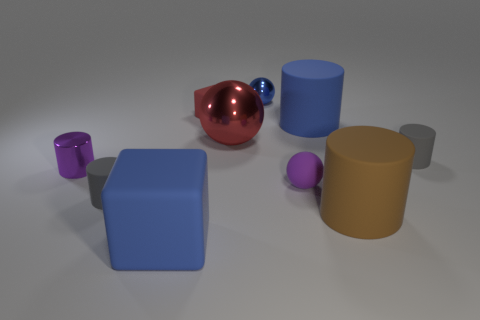Subtract all blue shiny spheres. How many spheres are left? 2 Subtract all gray blocks. How many gray cylinders are left? 2 Subtract all blue blocks. How many blocks are left? 1 Subtract 1 blocks. How many blocks are left? 1 Subtract all cubes. How many objects are left? 8 Subtract all large rubber things. Subtract all tiny red rubber cubes. How many objects are left? 6 Add 1 big cylinders. How many big cylinders are left? 3 Add 5 cyan rubber objects. How many cyan rubber objects exist? 5 Subtract 2 gray cylinders. How many objects are left? 8 Subtract all purple blocks. Subtract all yellow cylinders. How many blocks are left? 2 